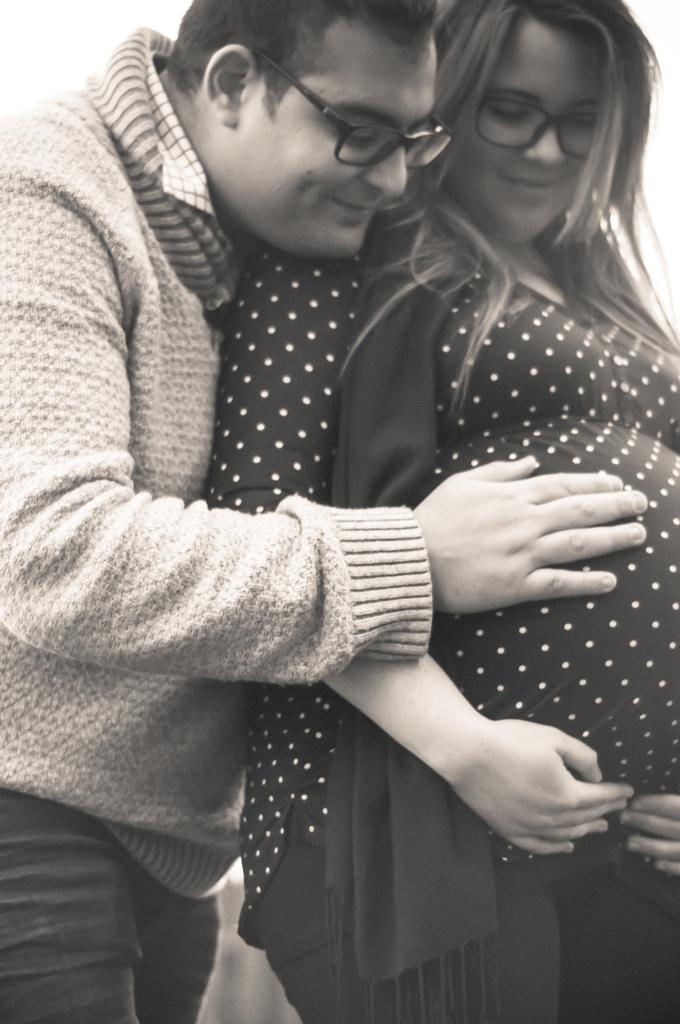How many people are in the image? There are two persons standing in the image. What is the person on the left wearing? The person on the left is wearing a jacket. What is the color scheme of the image? The image is in black and white. What type of dinner is being served to the judge in the image? There is no judge or dinner present in the image; it features two persons standing. How many tickets are visible in the image? There are no tickets visible in the image. 